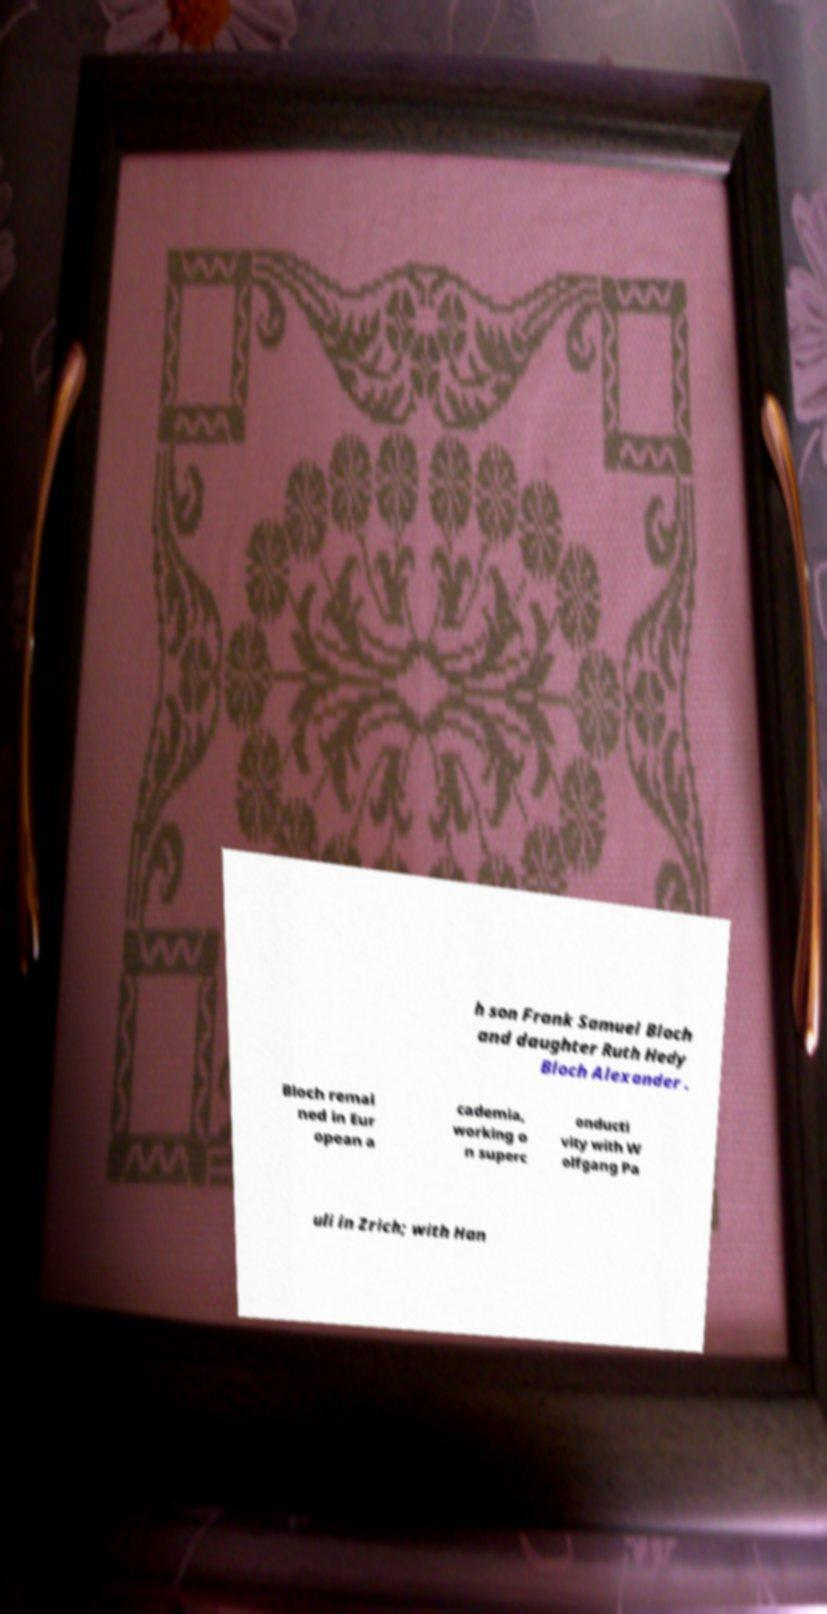I need the written content from this picture converted into text. Can you do that? h son Frank Samuel Bloch and daughter Ruth Hedy Bloch Alexander . Bloch remai ned in Eur opean a cademia, working o n superc onducti vity with W olfgang Pa uli in Zrich; with Han 